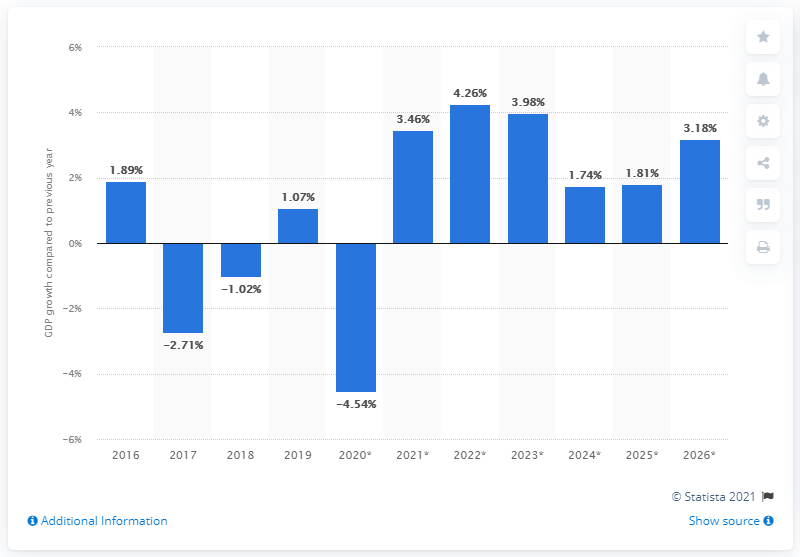Highlight a few significant elements in this photo. In 2026, the real Gross Domestic Product of Lesotho grew to a certain value. Lesotho's real Gross Domestic Product (GDP) increased by 1.07% in 2019. 